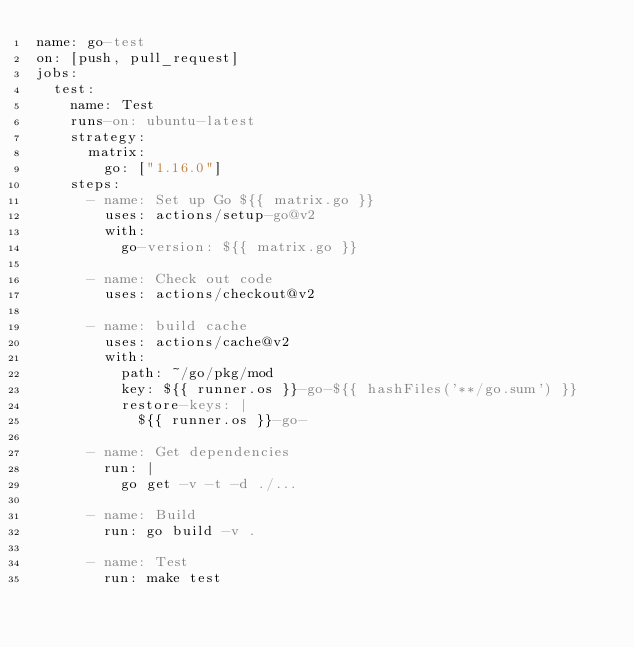<code> <loc_0><loc_0><loc_500><loc_500><_YAML_>name: go-test
on: [push, pull_request]
jobs:
  test:
    name: Test
    runs-on: ubuntu-latest
    strategy:
      matrix:
        go: ["1.16.0"]
    steps:
      - name: Set up Go ${{ matrix.go }}
        uses: actions/setup-go@v2
        with:
          go-version: ${{ matrix.go }}

      - name: Check out code
        uses: actions/checkout@v2

      - name: build cache
        uses: actions/cache@v2
        with:
          path: ~/go/pkg/mod
          key: ${{ runner.os }}-go-${{ hashFiles('**/go.sum') }}
          restore-keys: |
            ${{ runner.os }}-go-

      - name: Get dependencies
        run: |
          go get -v -t -d ./...

      - name: Build
        run: go build -v .

      - name: Test
        run: make test</code> 